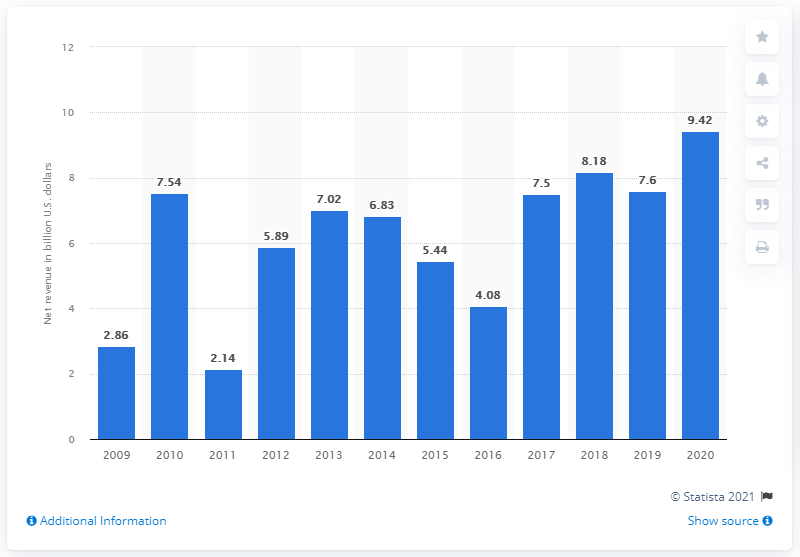Specify some key components in this picture. In 2020, the net revenue from investing and lending at Goldman Sachs was $9.42 billion. 